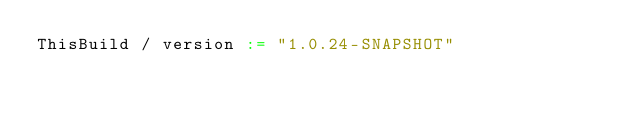<code> <loc_0><loc_0><loc_500><loc_500><_Scala_>ThisBuild / version := "1.0.24-SNAPSHOT"
</code> 